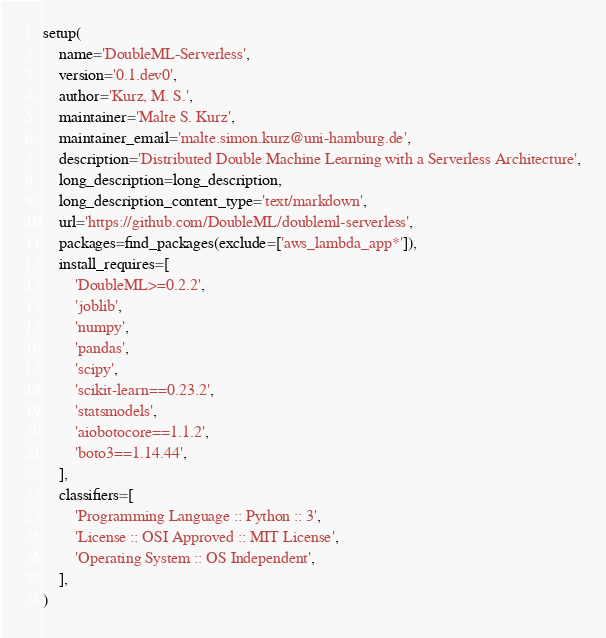Convert code to text. <code><loc_0><loc_0><loc_500><loc_500><_Python_>
setup(
    name='DoubleML-Serverless',
    version='0.1.dev0',
    author='Kurz, M. S.',
    maintainer='Malte S. Kurz',
    maintainer_email='malte.simon.kurz@uni-hamburg.de',
    description='Distributed Double Machine Learning with a Serverless Architecture',
    long_description=long_description,
    long_description_content_type='text/markdown',
    url='https://github.com/DoubleML/doubleml-serverless',
    packages=find_packages(exclude=['aws_lambda_app*']),
    install_requires=[
        'DoubleML>=0.2.2',
        'joblib',
        'numpy',
        'pandas',
        'scipy',
        'scikit-learn==0.23.2',
        'statsmodels',
        'aiobotocore==1.1.2',
        'boto3==1.14.44',
    ],
    classifiers=[
        'Programming Language :: Python :: 3',
        'License :: OSI Approved :: MIT License',
        'Operating System :: OS Independent',
    ],
)
</code> 